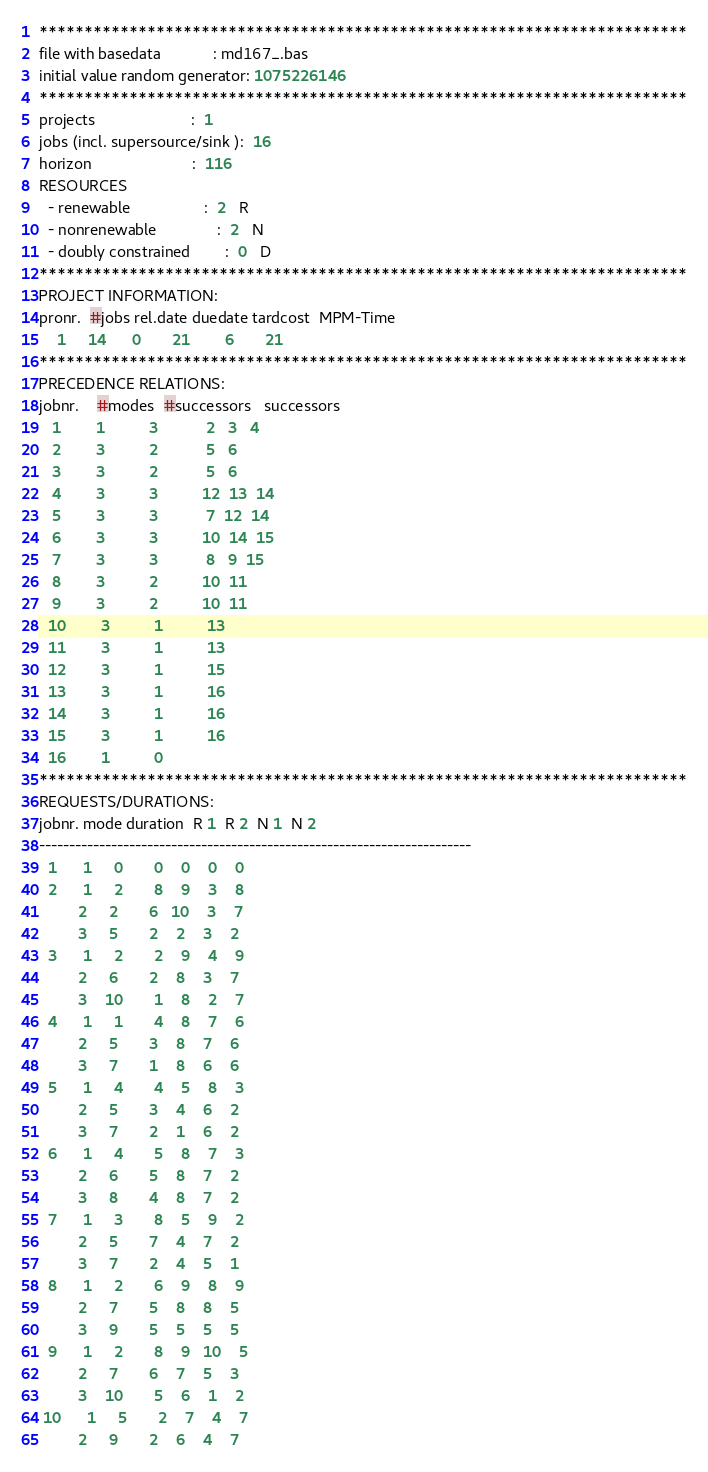Convert code to text. <code><loc_0><loc_0><loc_500><loc_500><_ObjectiveC_>************************************************************************
file with basedata            : md167_.bas
initial value random generator: 1075226146
************************************************************************
projects                      :  1
jobs (incl. supersource/sink ):  16
horizon                       :  116
RESOURCES
  - renewable                 :  2   R
  - nonrenewable              :  2   N
  - doubly constrained        :  0   D
************************************************************************
PROJECT INFORMATION:
pronr.  #jobs rel.date duedate tardcost  MPM-Time
    1     14      0       21        6       21
************************************************************************
PRECEDENCE RELATIONS:
jobnr.    #modes  #successors   successors
   1        1          3           2   3   4
   2        3          2           5   6
   3        3          2           5   6
   4        3          3          12  13  14
   5        3          3           7  12  14
   6        3          3          10  14  15
   7        3          3           8   9  15
   8        3          2          10  11
   9        3          2          10  11
  10        3          1          13
  11        3          1          13
  12        3          1          15
  13        3          1          16
  14        3          1          16
  15        3          1          16
  16        1          0        
************************************************************************
REQUESTS/DURATIONS:
jobnr. mode duration  R 1  R 2  N 1  N 2
------------------------------------------------------------------------
  1      1     0       0    0    0    0
  2      1     2       8    9    3    8
         2     2       6   10    3    7
         3     5       2    2    3    2
  3      1     2       2    9    4    9
         2     6       2    8    3    7
         3    10       1    8    2    7
  4      1     1       4    8    7    6
         2     5       3    8    7    6
         3     7       1    8    6    6
  5      1     4       4    5    8    3
         2     5       3    4    6    2
         3     7       2    1    6    2
  6      1     4       5    8    7    3
         2     6       5    8    7    2
         3     8       4    8    7    2
  7      1     3       8    5    9    2
         2     5       7    4    7    2
         3     7       2    4    5    1
  8      1     2       6    9    8    9
         2     7       5    8    8    5
         3     9       5    5    5    5
  9      1     2       8    9   10    5
         2     7       6    7    5    3
         3    10       5    6    1    2
 10      1     5       2    7    4    7
         2     9       2    6    4    7</code> 